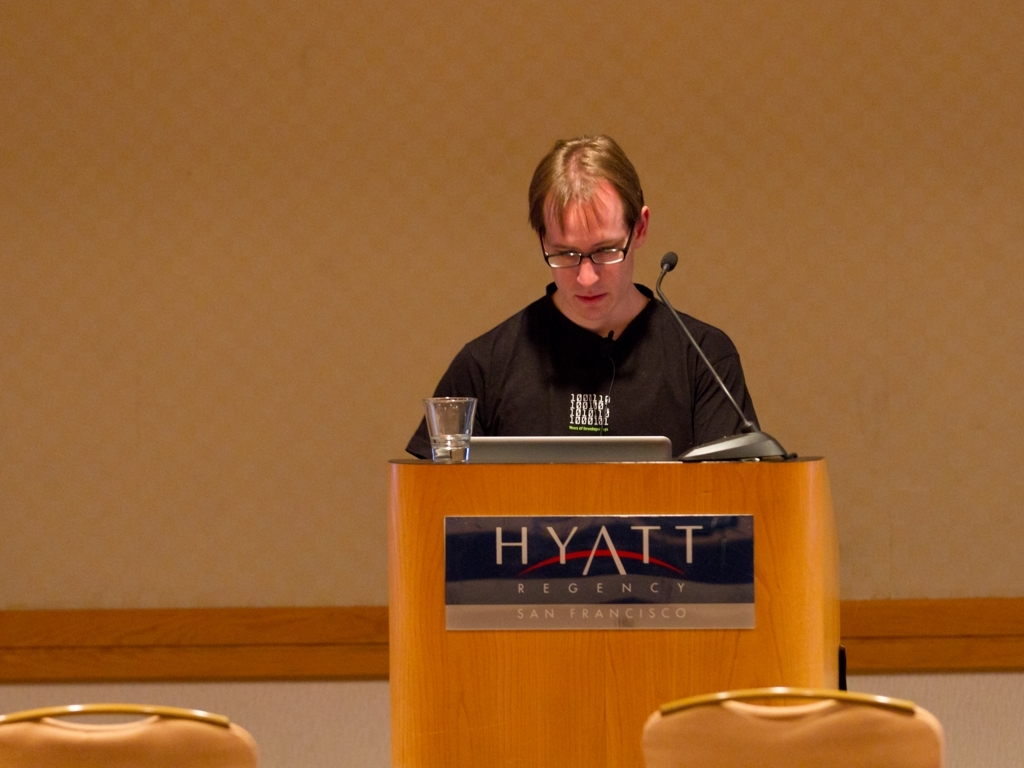What could be improved in the composition of this photograph? To enhance the composition, a photographer could consider closer framing on the subject to reduce distractions, adjust lighting to brighten the scene evenly, and focus more precisely to ensure that the subject is sharp. Additionally, capturing the audience's reaction could add context and dynamism to the image. 